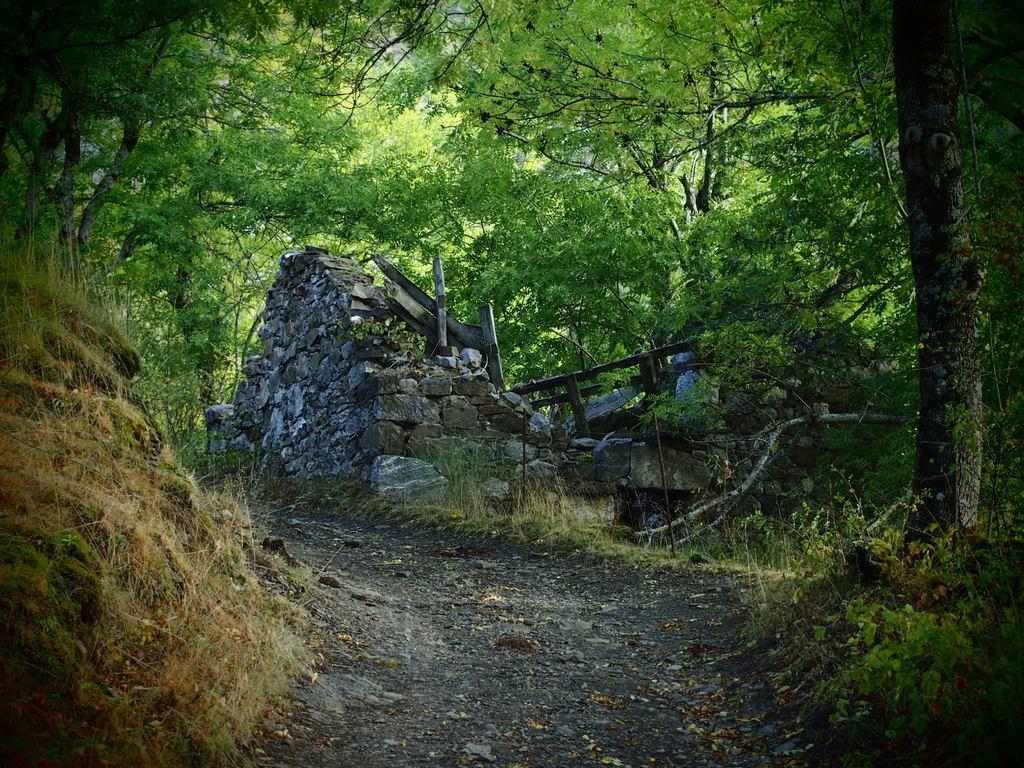In one or two sentences, can you explain what this image depicts? In this image at the center there is a road. On both right and left side of the image there is a grass on the surface. At the background there are rocks and trees. 